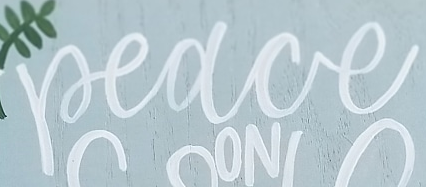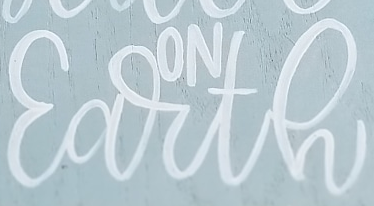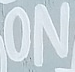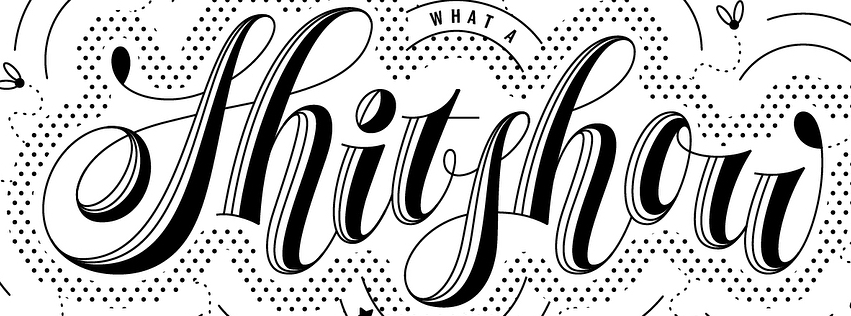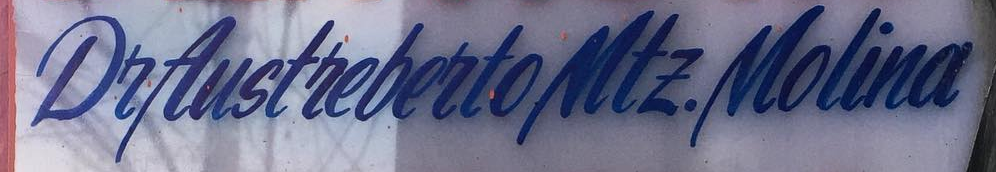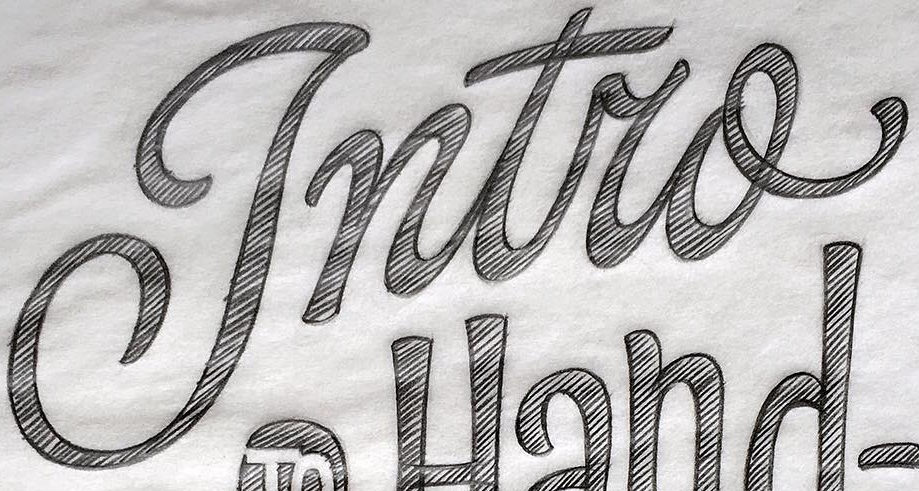Read the text from these images in sequence, separated by a semicolon. Peace; Earth; ON; Shitshou; DeAustrebertoMtE.Molina; Intro 